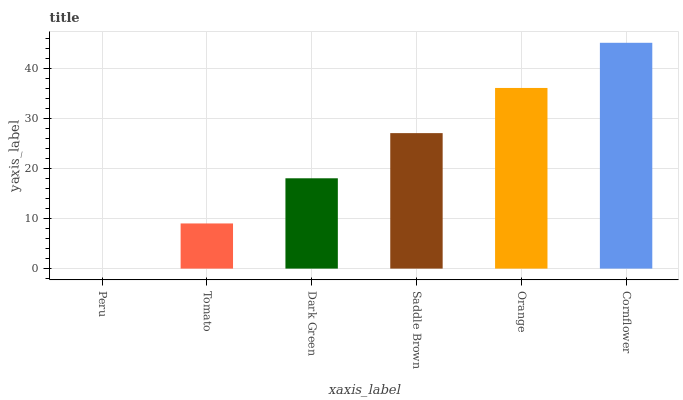Is Peru the minimum?
Answer yes or no. Yes. Is Cornflower the maximum?
Answer yes or no. Yes. Is Tomato the minimum?
Answer yes or no. No. Is Tomato the maximum?
Answer yes or no. No. Is Tomato greater than Peru?
Answer yes or no. Yes. Is Peru less than Tomato?
Answer yes or no. Yes. Is Peru greater than Tomato?
Answer yes or no. No. Is Tomato less than Peru?
Answer yes or no. No. Is Saddle Brown the high median?
Answer yes or no. Yes. Is Dark Green the low median?
Answer yes or no. Yes. Is Cornflower the high median?
Answer yes or no. No. Is Saddle Brown the low median?
Answer yes or no. No. 